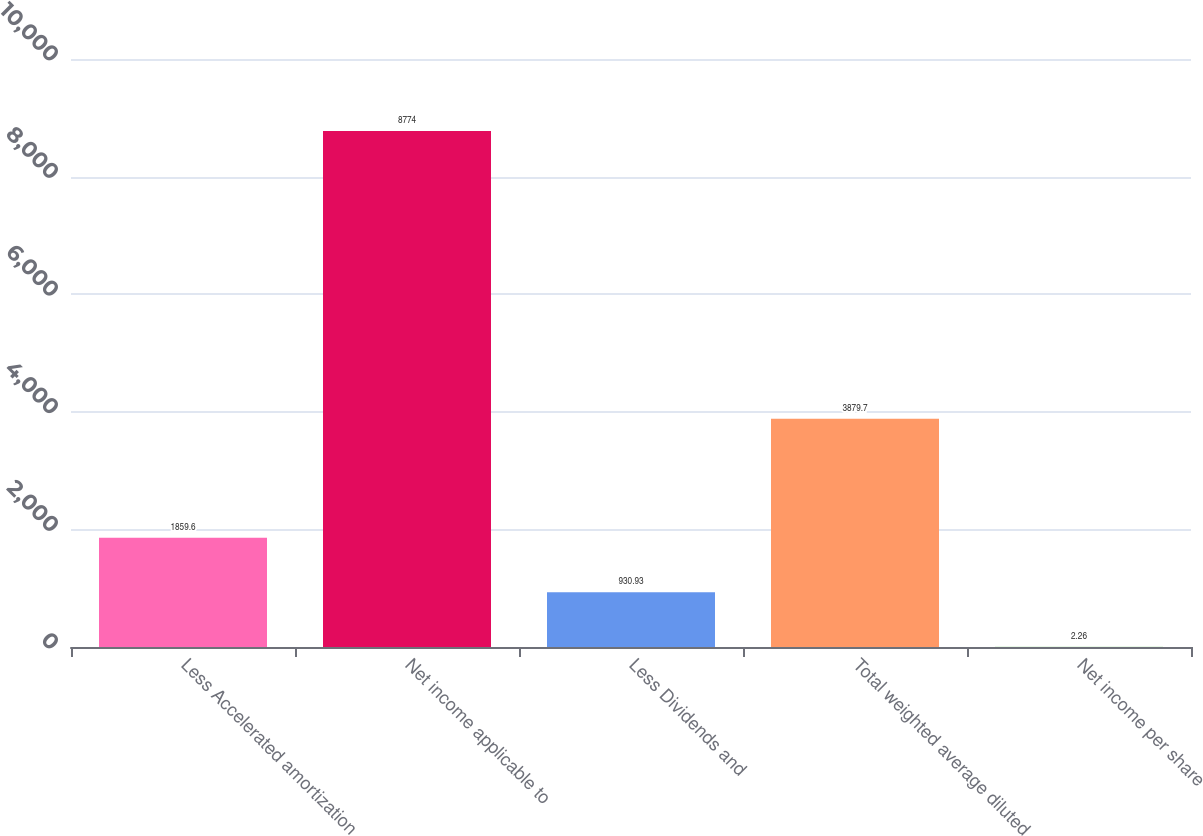Convert chart. <chart><loc_0><loc_0><loc_500><loc_500><bar_chart><fcel>Less Accelerated amortization<fcel>Net income applicable to<fcel>Less Dividends and<fcel>Total weighted average diluted<fcel>Net income per share<nl><fcel>1859.6<fcel>8774<fcel>930.93<fcel>3879.7<fcel>2.26<nl></chart> 